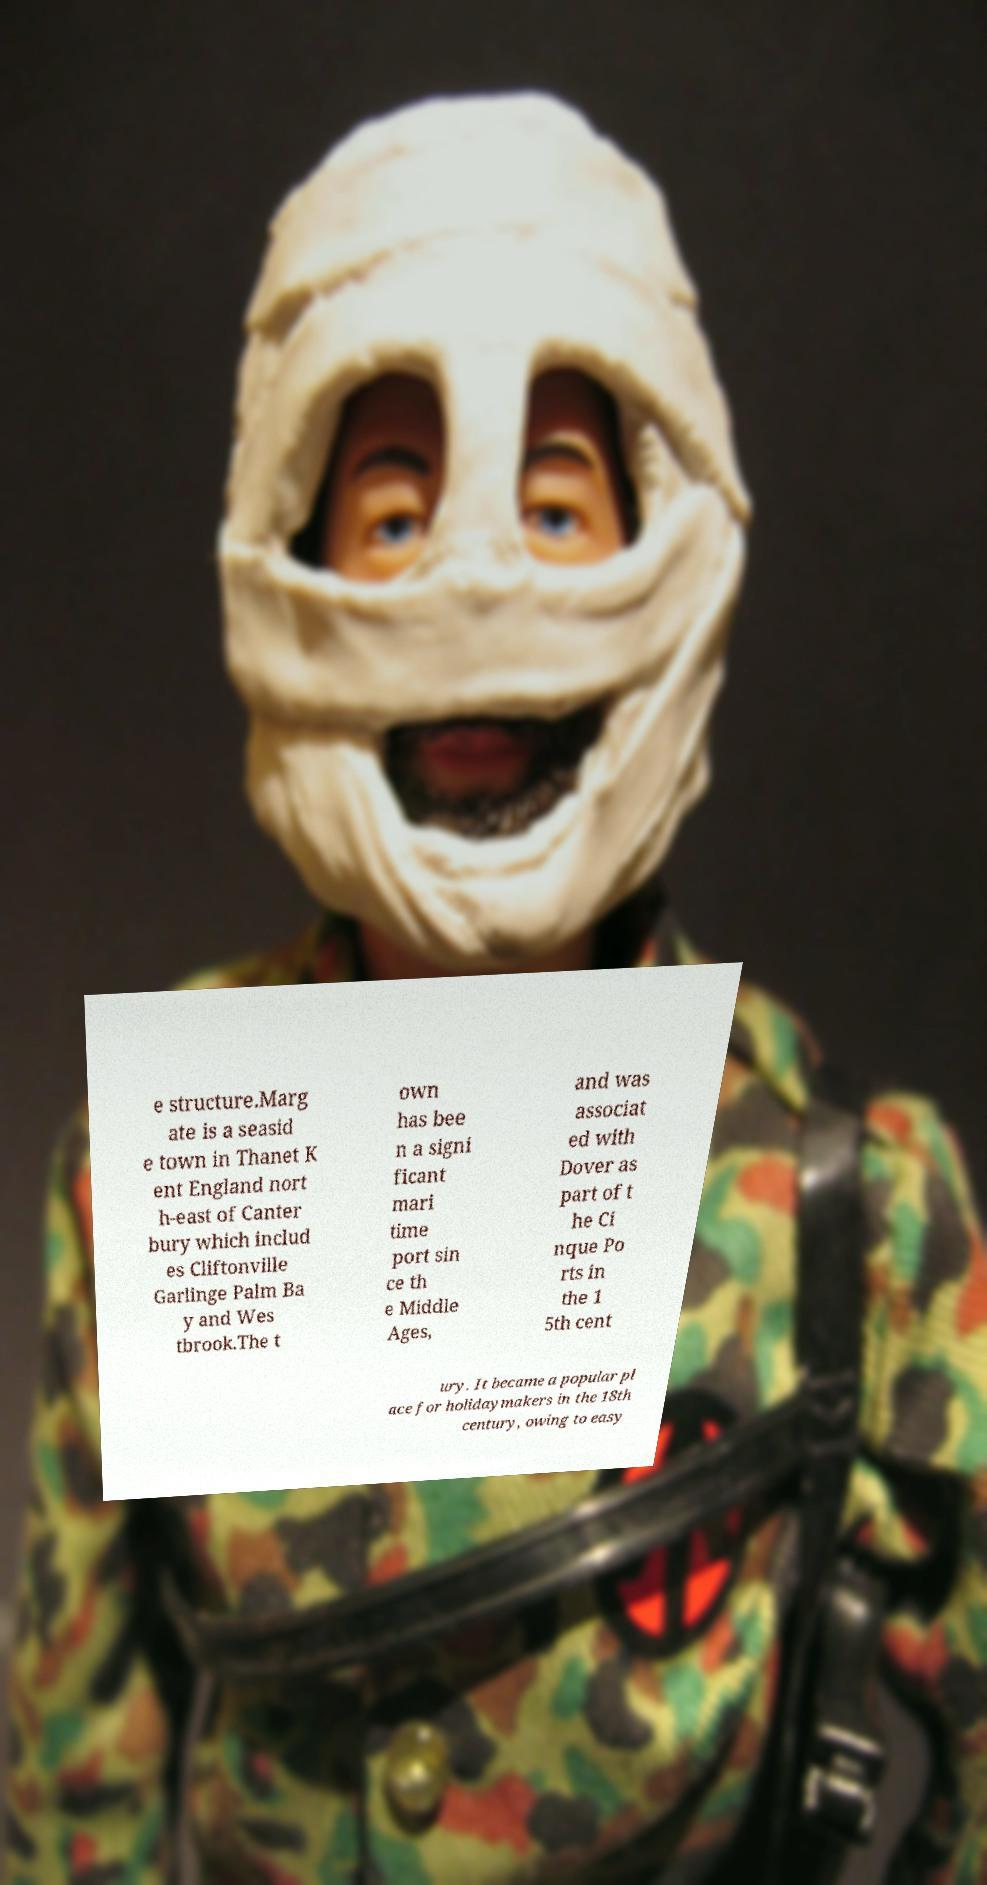Could you assist in decoding the text presented in this image and type it out clearly? e structure.Marg ate is a seasid e town in Thanet K ent England nort h-east of Canter bury which includ es Cliftonville Garlinge Palm Ba y and Wes tbrook.The t own has bee n a signi ficant mari time port sin ce th e Middle Ages, and was associat ed with Dover as part of t he Ci nque Po rts in the 1 5th cent ury. It became a popular pl ace for holidaymakers in the 18th century, owing to easy 